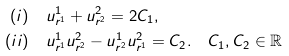<formula> <loc_0><loc_0><loc_500><loc_500>( i ) & \quad u ^ { 1 } _ { r ^ { 1 } } + u ^ { 2 } _ { r ^ { 2 } } = 2 C _ { 1 } , \\ ( i i ) & \quad u ^ { 1 } _ { r ^ { 1 } } u ^ { 2 } _ { r ^ { 2 } } - u ^ { 1 } _ { r ^ { 2 } } u ^ { 2 } _ { r ^ { 1 } } = C _ { 2 } . \quad C _ { 1 } , C _ { 2 } \in \mathbb { R }</formula> 